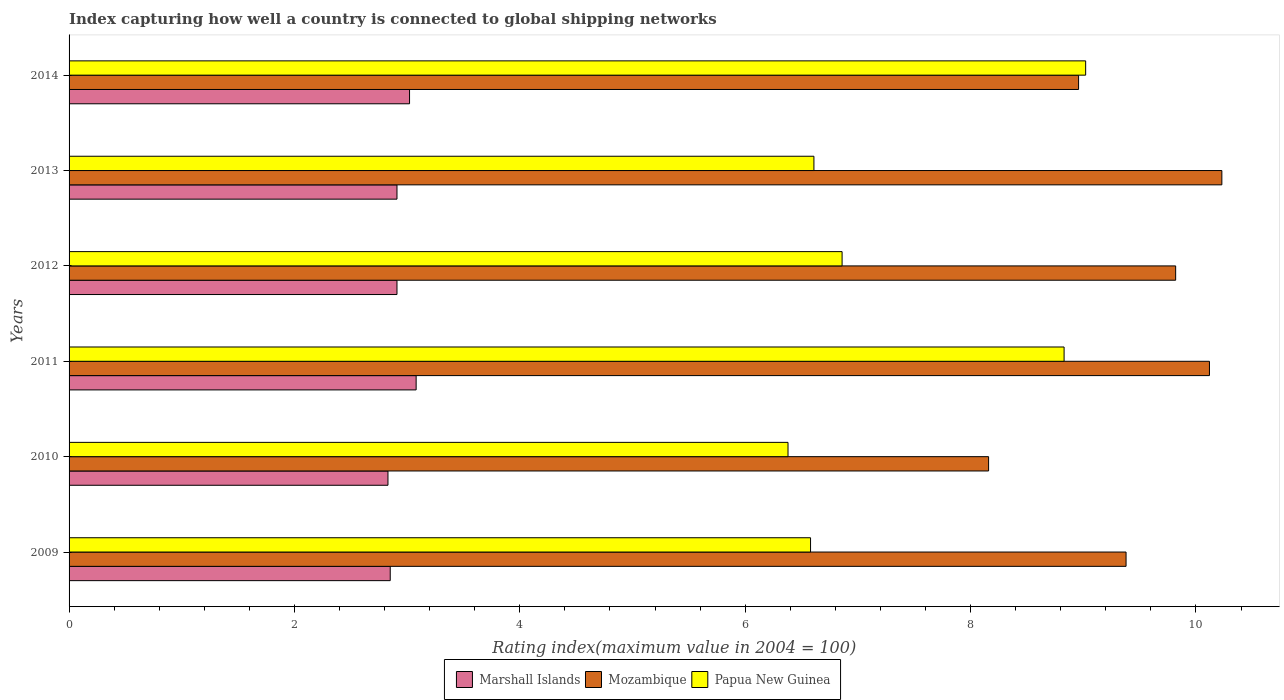How many groups of bars are there?
Offer a very short reply. 6. Are the number of bars on each tick of the Y-axis equal?
Offer a very short reply. Yes. How many bars are there on the 2nd tick from the top?
Provide a short and direct response. 3. How many bars are there on the 4th tick from the bottom?
Your answer should be very brief. 3. What is the rating index in Marshall Islands in 2010?
Provide a short and direct response. 2.83. Across all years, what is the maximum rating index in Mozambique?
Your answer should be compact. 10.23. Across all years, what is the minimum rating index in Papua New Guinea?
Provide a succinct answer. 6.38. In which year was the rating index in Mozambique minimum?
Give a very brief answer. 2010. What is the total rating index in Marshall Islands in the graph?
Your response must be concise. 17.6. What is the difference between the rating index in Papua New Guinea in 2010 and that in 2013?
Your answer should be compact. -0.23. What is the difference between the rating index in Marshall Islands in 2009 and the rating index in Papua New Guinea in 2012?
Make the answer very short. -4.01. What is the average rating index in Papua New Guinea per year?
Give a very brief answer. 7.38. In the year 2010, what is the difference between the rating index in Papua New Guinea and rating index in Mozambique?
Provide a succinct answer. -1.78. In how many years, is the rating index in Marshall Islands greater than 8.8 ?
Your answer should be very brief. 0. What is the ratio of the rating index in Marshall Islands in 2011 to that in 2012?
Your answer should be compact. 1.06. Is the difference between the rating index in Papua New Guinea in 2011 and 2014 greater than the difference between the rating index in Mozambique in 2011 and 2014?
Keep it short and to the point. No. What is the difference between the highest and the second highest rating index in Marshall Islands?
Give a very brief answer. 0.06. What is the difference between the highest and the lowest rating index in Marshall Islands?
Provide a short and direct response. 0.25. In how many years, is the rating index in Mozambique greater than the average rating index in Mozambique taken over all years?
Offer a terse response. 3. What does the 2nd bar from the top in 2011 represents?
Give a very brief answer. Mozambique. What does the 2nd bar from the bottom in 2013 represents?
Provide a short and direct response. Mozambique. Is it the case that in every year, the sum of the rating index in Marshall Islands and rating index in Mozambique is greater than the rating index in Papua New Guinea?
Give a very brief answer. Yes. How many bars are there?
Give a very brief answer. 18. Are all the bars in the graph horizontal?
Offer a very short reply. Yes. Does the graph contain grids?
Keep it short and to the point. No. Where does the legend appear in the graph?
Offer a very short reply. Bottom center. What is the title of the graph?
Make the answer very short. Index capturing how well a country is connected to global shipping networks. What is the label or title of the X-axis?
Your answer should be compact. Rating index(maximum value in 2004 = 100). What is the Rating index(maximum value in 2004 = 100) in Marshall Islands in 2009?
Make the answer very short. 2.85. What is the Rating index(maximum value in 2004 = 100) in Mozambique in 2009?
Ensure brevity in your answer.  9.38. What is the Rating index(maximum value in 2004 = 100) in Papua New Guinea in 2009?
Ensure brevity in your answer.  6.58. What is the Rating index(maximum value in 2004 = 100) of Marshall Islands in 2010?
Offer a very short reply. 2.83. What is the Rating index(maximum value in 2004 = 100) of Mozambique in 2010?
Provide a succinct answer. 8.16. What is the Rating index(maximum value in 2004 = 100) in Papua New Guinea in 2010?
Your response must be concise. 6.38. What is the Rating index(maximum value in 2004 = 100) in Marshall Islands in 2011?
Your response must be concise. 3.08. What is the Rating index(maximum value in 2004 = 100) in Mozambique in 2011?
Offer a terse response. 10.12. What is the Rating index(maximum value in 2004 = 100) of Papua New Guinea in 2011?
Offer a terse response. 8.83. What is the Rating index(maximum value in 2004 = 100) in Marshall Islands in 2012?
Give a very brief answer. 2.91. What is the Rating index(maximum value in 2004 = 100) in Mozambique in 2012?
Provide a succinct answer. 9.82. What is the Rating index(maximum value in 2004 = 100) in Papua New Guinea in 2012?
Your response must be concise. 6.86. What is the Rating index(maximum value in 2004 = 100) of Marshall Islands in 2013?
Ensure brevity in your answer.  2.91. What is the Rating index(maximum value in 2004 = 100) in Mozambique in 2013?
Provide a succinct answer. 10.23. What is the Rating index(maximum value in 2004 = 100) in Papua New Guinea in 2013?
Provide a succinct answer. 6.61. What is the Rating index(maximum value in 2004 = 100) in Marshall Islands in 2014?
Offer a very short reply. 3.02. What is the Rating index(maximum value in 2004 = 100) of Mozambique in 2014?
Your response must be concise. 8.96. What is the Rating index(maximum value in 2004 = 100) in Papua New Guinea in 2014?
Your response must be concise. 9.02. Across all years, what is the maximum Rating index(maximum value in 2004 = 100) in Marshall Islands?
Give a very brief answer. 3.08. Across all years, what is the maximum Rating index(maximum value in 2004 = 100) of Mozambique?
Give a very brief answer. 10.23. Across all years, what is the maximum Rating index(maximum value in 2004 = 100) in Papua New Guinea?
Give a very brief answer. 9.02. Across all years, what is the minimum Rating index(maximum value in 2004 = 100) of Marshall Islands?
Your answer should be compact. 2.83. Across all years, what is the minimum Rating index(maximum value in 2004 = 100) of Mozambique?
Provide a succinct answer. 8.16. Across all years, what is the minimum Rating index(maximum value in 2004 = 100) of Papua New Guinea?
Ensure brevity in your answer.  6.38. What is the total Rating index(maximum value in 2004 = 100) of Marshall Islands in the graph?
Offer a terse response. 17.6. What is the total Rating index(maximum value in 2004 = 100) in Mozambique in the graph?
Provide a short and direct response. 56.67. What is the total Rating index(maximum value in 2004 = 100) in Papua New Guinea in the graph?
Offer a terse response. 44.28. What is the difference between the Rating index(maximum value in 2004 = 100) in Mozambique in 2009 and that in 2010?
Provide a succinct answer. 1.22. What is the difference between the Rating index(maximum value in 2004 = 100) of Marshall Islands in 2009 and that in 2011?
Your answer should be very brief. -0.23. What is the difference between the Rating index(maximum value in 2004 = 100) in Mozambique in 2009 and that in 2011?
Your answer should be very brief. -0.74. What is the difference between the Rating index(maximum value in 2004 = 100) in Papua New Guinea in 2009 and that in 2011?
Your response must be concise. -2.25. What is the difference between the Rating index(maximum value in 2004 = 100) in Marshall Islands in 2009 and that in 2012?
Provide a succinct answer. -0.06. What is the difference between the Rating index(maximum value in 2004 = 100) in Mozambique in 2009 and that in 2012?
Keep it short and to the point. -0.44. What is the difference between the Rating index(maximum value in 2004 = 100) of Papua New Guinea in 2009 and that in 2012?
Provide a short and direct response. -0.28. What is the difference between the Rating index(maximum value in 2004 = 100) of Marshall Islands in 2009 and that in 2013?
Your answer should be very brief. -0.06. What is the difference between the Rating index(maximum value in 2004 = 100) of Mozambique in 2009 and that in 2013?
Your answer should be compact. -0.85. What is the difference between the Rating index(maximum value in 2004 = 100) in Papua New Guinea in 2009 and that in 2013?
Provide a short and direct response. -0.03. What is the difference between the Rating index(maximum value in 2004 = 100) of Marshall Islands in 2009 and that in 2014?
Your answer should be very brief. -0.17. What is the difference between the Rating index(maximum value in 2004 = 100) of Mozambique in 2009 and that in 2014?
Offer a terse response. 0.42. What is the difference between the Rating index(maximum value in 2004 = 100) of Papua New Guinea in 2009 and that in 2014?
Give a very brief answer. -2.44. What is the difference between the Rating index(maximum value in 2004 = 100) in Mozambique in 2010 and that in 2011?
Your response must be concise. -1.96. What is the difference between the Rating index(maximum value in 2004 = 100) in Papua New Guinea in 2010 and that in 2011?
Keep it short and to the point. -2.45. What is the difference between the Rating index(maximum value in 2004 = 100) in Marshall Islands in 2010 and that in 2012?
Provide a succinct answer. -0.08. What is the difference between the Rating index(maximum value in 2004 = 100) of Mozambique in 2010 and that in 2012?
Make the answer very short. -1.66. What is the difference between the Rating index(maximum value in 2004 = 100) of Papua New Guinea in 2010 and that in 2012?
Your answer should be very brief. -0.48. What is the difference between the Rating index(maximum value in 2004 = 100) in Marshall Islands in 2010 and that in 2013?
Your response must be concise. -0.08. What is the difference between the Rating index(maximum value in 2004 = 100) of Mozambique in 2010 and that in 2013?
Keep it short and to the point. -2.07. What is the difference between the Rating index(maximum value in 2004 = 100) in Papua New Guinea in 2010 and that in 2013?
Your answer should be very brief. -0.23. What is the difference between the Rating index(maximum value in 2004 = 100) of Marshall Islands in 2010 and that in 2014?
Offer a terse response. -0.19. What is the difference between the Rating index(maximum value in 2004 = 100) in Mozambique in 2010 and that in 2014?
Your response must be concise. -0.8. What is the difference between the Rating index(maximum value in 2004 = 100) of Papua New Guinea in 2010 and that in 2014?
Your response must be concise. -2.64. What is the difference between the Rating index(maximum value in 2004 = 100) of Marshall Islands in 2011 and that in 2012?
Ensure brevity in your answer.  0.17. What is the difference between the Rating index(maximum value in 2004 = 100) in Papua New Guinea in 2011 and that in 2012?
Keep it short and to the point. 1.97. What is the difference between the Rating index(maximum value in 2004 = 100) of Marshall Islands in 2011 and that in 2013?
Make the answer very short. 0.17. What is the difference between the Rating index(maximum value in 2004 = 100) of Mozambique in 2011 and that in 2013?
Provide a short and direct response. -0.11. What is the difference between the Rating index(maximum value in 2004 = 100) of Papua New Guinea in 2011 and that in 2013?
Provide a short and direct response. 2.22. What is the difference between the Rating index(maximum value in 2004 = 100) of Marshall Islands in 2011 and that in 2014?
Give a very brief answer. 0.06. What is the difference between the Rating index(maximum value in 2004 = 100) of Mozambique in 2011 and that in 2014?
Your answer should be compact. 1.16. What is the difference between the Rating index(maximum value in 2004 = 100) of Papua New Guinea in 2011 and that in 2014?
Offer a terse response. -0.19. What is the difference between the Rating index(maximum value in 2004 = 100) in Mozambique in 2012 and that in 2013?
Your response must be concise. -0.41. What is the difference between the Rating index(maximum value in 2004 = 100) in Papua New Guinea in 2012 and that in 2013?
Ensure brevity in your answer.  0.25. What is the difference between the Rating index(maximum value in 2004 = 100) of Marshall Islands in 2012 and that in 2014?
Keep it short and to the point. -0.11. What is the difference between the Rating index(maximum value in 2004 = 100) of Mozambique in 2012 and that in 2014?
Your answer should be very brief. 0.86. What is the difference between the Rating index(maximum value in 2004 = 100) of Papua New Guinea in 2012 and that in 2014?
Provide a short and direct response. -2.16. What is the difference between the Rating index(maximum value in 2004 = 100) of Marshall Islands in 2013 and that in 2014?
Give a very brief answer. -0.11. What is the difference between the Rating index(maximum value in 2004 = 100) of Mozambique in 2013 and that in 2014?
Offer a terse response. 1.27. What is the difference between the Rating index(maximum value in 2004 = 100) in Papua New Guinea in 2013 and that in 2014?
Ensure brevity in your answer.  -2.41. What is the difference between the Rating index(maximum value in 2004 = 100) in Marshall Islands in 2009 and the Rating index(maximum value in 2004 = 100) in Mozambique in 2010?
Your answer should be compact. -5.31. What is the difference between the Rating index(maximum value in 2004 = 100) of Marshall Islands in 2009 and the Rating index(maximum value in 2004 = 100) of Papua New Guinea in 2010?
Keep it short and to the point. -3.53. What is the difference between the Rating index(maximum value in 2004 = 100) of Mozambique in 2009 and the Rating index(maximum value in 2004 = 100) of Papua New Guinea in 2010?
Offer a terse response. 3. What is the difference between the Rating index(maximum value in 2004 = 100) in Marshall Islands in 2009 and the Rating index(maximum value in 2004 = 100) in Mozambique in 2011?
Provide a succinct answer. -7.27. What is the difference between the Rating index(maximum value in 2004 = 100) of Marshall Islands in 2009 and the Rating index(maximum value in 2004 = 100) of Papua New Guinea in 2011?
Offer a terse response. -5.98. What is the difference between the Rating index(maximum value in 2004 = 100) in Mozambique in 2009 and the Rating index(maximum value in 2004 = 100) in Papua New Guinea in 2011?
Give a very brief answer. 0.55. What is the difference between the Rating index(maximum value in 2004 = 100) of Marshall Islands in 2009 and the Rating index(maximum value in 2004 = 100) of Mozambique in 2012?
Offer a terse response. -6.97. What is the difference between the Rating index(maximum value in 2004 = 100) of Marshall Islands in 2009 and the Rating index(maximum value in 2004 = 100) of Papua New Guinea in 2012?
Your answer should be compact. -4.01. What is the difference between the Rating index(maximum value in 2004 = 100) in Mozambique in 2009 and the Rating index(maximum value in 2004 = 100) in Papua New Guinea in 2012?
Provide a succinct answer. 2.52. What is the difference between the Rating index(maximum value in 2004 = 100) of Marshall Islands in 2009 and the Rating index(maximum value in 2004 = 100) of Mozambique in 2013?
Give a very brief answer. -7.38. What is the difference between the Rating index(maximum value in 2004 = 100) in Marshall Islands in 2009 and the Rating index(maximum value in 2004 = 100) in Papua New Guinea in 2013?
Make the answer very short. -3.76. What is the difference between the Rating index(maximum value in 2004 = 100) of Mozambique in 2009 and the Rating index(maximum value in 2004 = 100) of Papua New Guinea in 2013?
Keep it short and to the point. 2.77. What is the difference between the Rating index(maximum value in 2004 = 100) in Marshall Islands in 2009 and the Rating index(maximum value in 2004 = 100) in Mozambique in 2014?
Your answer should be very brief. -6.11. What is the difference between the Rating index(maximum value in 2004 = 100) in Marshall Islands in 2009 and the Rating index(maximum value in 2004 = 100) in Papua New Guinea in 2014?
Give a very brief answer. -6.17. What is the difference between the Rating index(maximum value in 2004 = 100) in Mozambique in 2009 and the Rating index(maximum value in 2004 = 100) in Papua New Guinea in 2014?
Keep it short and to the point. 0.36. What is the difference between the Rating index(maximum value in 2004 = 100) of Marshall Islands in 2010 and the Rating index(maximum value in 2004 = 100) of Mozambique in 2011?
Your answer should be compact. -7.29. What is the difference between the Rating index(maximum value in 2004 = 100) in Mozambique in 2010 and the Rating index(maximum value in 2004 = 100) in Papua New Guinea in 2011?
Your answer should be compact. -0.67. What is the difference between the Rating index(maximum value in 2004 = 100) of Marshall Islands in 2010 and the Rating index(maximum value in 2004 = 100) of Mozambique in 2012?
Offer a terse response. -6.99. What is the difference between the Rating index(maximum value in 2004 = 100) of Marshall Islands in 2010 and the Rating index(maximum value in 2004 = 100) of Papua New Guinea in 2012?
Your answer should be very brief. -4.03. What is the difference between the Rating index(maximum value in 2004 = 100) of Marshall Islands in 2010 and the Rating index(maximum value in 2004 = 100) of Mozambique in 2013?
Offer a terse response. -7.4. What is the difference between the Rating index(maximum value in 2004 = 100) of Marshall Islands in 2010 and the Rating index(maximum value in 2004 = 100) of Papua New Guinea in 2013?
Your response must be concise. -3.78. What is the difference between the Rating index(maximum value in 2004 = 100) in Mozambique in 2010 and the Rating index(maximum value in 2004 = 100) in Papua New Guinea in 2013?
Offer a very short reply. 1.55. What is the difference between the Rating index(maximum value in 2004 = 100) in Marshall Islands in 2010 and the Rating index(maximum value in 2004 = 100) in Mozambique in 2014?
Provide a short and direct response. -6.13. What is the difference between the Rating index(maximum value in 2004 = 100) in Marshall Islands in 2010 and the Rating index(maximum value in 2004 = 100) in Papua New Guinea in 2014?
Your answer should be compact. -6.19. What is the difference between the Rating index(maximum value in 2004 = 100) in Mozambique in 2010 and the Rating index(maximum value in 2004 = 100) in Papua New Guinea in 2014?
Provide a short and direct response. -0.86. What is the difference between the Rating index(maximum value in 2004 = 100) of Marshall Islands in 2011 and the Rating index(maximum value in 2004 = 100) of Mozambique in 2012?
Your answer should be compact. -6.74. What is the difference between the Rating index(maximum value in 2004 = 100) of Marshall Islands in 2011 and the Rating index(maximum value in 2004 = 100) of Papua New Guinea in 2012?
Provide a short and direct response. -3.78. What is the difference between the Rating index(maximum value in 2004 = 100) of Mozambique in 2011 and the Rating index(maximum value in 2004 = 100) of Papua New Guinea in 2012?
Offer a terse response. 3.26. What is the difference between the Rating index(maximum value in 2004 = 100) of Marshall Islands in 2011 and the Rating index(maximum value in 2004 = 100) of Mozambique in 2013?
Your answer should be very brief. -7.15. What is the difference between the Rating index(maximum value in 2004 = 100) in Marshall Islands in 2011 and the Rating index(maximum value in 2004 = 100) in Papua New Guinea in 2013?
Your answer should be very brief. -3.53. What is the difference between the Rating index(maximum value in 2004 = 100) in Mozambique in 2011 and the Rating index(maximum value in 2004 = 100) in Papua New Guinea in 2013?
Offer a very short reply. 3.51. What is the difference between the Rating index(maximum value in 2004 = 100) in Marshall Islands in 2011 and the Rating index(maximum value in 2004 = 100) in Mozambique in 2014?
Make the answer very short. -5.88. What is the difference between the Rating index(maximum value in 2004 = 100) of Marshall Islands in 2011 and the Rating index(maximum value in 2004 = 100) of Papua New Guinea in 2014?
Give a very brief answer. -5.94. What is the difference between the Rating index(maximum value in 2004 = 100) in Mozambique in 2011 and the Rating index(maximum value in 2004 = 100) in Papua New Guinea in 2014?
Provide a short and direct response. 1.1. What is the difference between the Rating index(maximum value in 2004 = 100) of Marshall Islands in 2012 and the Rating index(maximum value in 2004 = 100) of Mozambique in 2013?
Offer a very short reply. -7.32. What is the difference between the Rating index(maximum value in 2004 = 100) of Mozambique in 2012 and the Rating index(maximum value in 2004 = 100) of Papua New Guinea in 2013?
Make the answer very short. 3.21. What is the difference between the Rating index(maximum value in 2004 = 100) of Marshall Islands in 2012 and the Rating index(maximum value in 2004 = 100) of Mozambique in 2014?
Offer a terse response. -6.05. What is the difference between the Rating index(maximum value in 2004 = 100) in Marshall Islands in 2012 and the Rating index(maximum value in 2004 = 100) in Papua New Guinea in 2014?
Keep it short and to the point. -6.11. What is the difference between the Rating index(maximum value in 2004 = 100) in Mozambique in 2012 and the Rating index(maximum value in 2004 = 100) in Papua New Guinea in 2014?
Give a very brief answer. 0.8. What is the difference between the Rating index(maximum value in 2004 = 100) of Marshall Islands in 2013 and the Rating index(maximum value in 2004 = 100) of Mozambique in 2014?
Make the answer very short. -6.05. What is the difference between the Rating index(maximum value in 2004 = 100) in Marshall Islands in 2013 and the Rating index(maximum value in 2004 = 100) in Papua New Guinea in 2014?
Keep it short and to the point. -6.11. What is the difference between the Rating index(maximum value in 2004 = 100) of Mozambique in 2013 and the Rating index(maximum value in 2004 = 100) of Papua New Guinea in 2014?
Offer a very short reply. 1.21. What is the average Rating index(maximum value in 2004 = 100) of Marshall Islands per year?
Make the answer very short. 2.93. What is the average Rating index(maximum value in 2004 = 100) in Mozambique per year?
Your answer should be compact. 9.44. What is the average Rating index(maximum value in 2004 = 100) in Papua New Guinea per year?
Ensure brevity in your answer.  7.38. In the year 2009, what is the difference between the Rating index(maximum value in 2004 = 100) in Marshall Islands and Rating index(maximum value in 2004 = 100) in Mozambique?
Offer a terse response. -6.53. In the year 2009, what is the difference between the Rating index(maximum value in 2004 = 100) in Marshall Islands and Rating index(maximum value in 2004 = 100) in Papua New Guinea?
Provide a succinct answer. -3.73. In the year 2010, what is the difference between the Rating index(maximum value in 2004 = 100) in Marshall Islands and Rating index(maximum value in 2004 = 100) in Mozambique?
Ensure brevity in your answer.  -5.33. In the year 2010, what is the difference between the Rating index(maximum value in 2004 = 100) of Marshall Islands and Rating index(maximum value in 2004 = 100) of Papua New Guinea?
Offer a very short reply. -3.55. In the year 2010, what is the difference between the Rating index(maximum value in 2004 = 100) in Mozambique and Rating index(maximum value in 2004 = 100) in Papua New Guinea?
Ensure brevity in your answer.  1.78. In the year 2011, what is the difference between the Rating index(maximum value in 2004 = 100) of Marshall Islands and Rating index(maximum value in 2004 = 100) of Mozambique?
Offer a terse response. -7.04. In the year 2011, what is the difference between the Rating index(maximum value in 2004 = 100) in Marshall Islands and Rating index(maximum value in 2004 = 100) in Papua New Guinea?
Your answer should be compact. -5.75. In the year 2011, what is the difference between the Rating index(maximum value in 2004 = 100) in Mozambique and Rating index(maximum value in 2004 = 100) in Papua New Guinea?
Offer a very short reply. 1.29. In the year 2012, what is the difference between the Rating index(maximum value in 2004 = 100) in Marshall Islands and Rating index(maximum value in 2004 = 100) in Mozambique?
Provide a succinct answer. -6.91. In the year 2012, what is the difference between the Rating index(maximum value in 2004 = 100) in Marshall Islands and Rating index(maximum value in 2004 = 100) in Papua New Guinea?
Give a very brief answer. -3.95. In the year 2012, what is the difference between the Rating index(maximum value in 2004 = 100) in Mozambique and Rating index(maximum value in 2004 = 100) in Papua New Guinea?
Your answer should be very brief. 2.96. In the year 2013, what is the difference between the Rating index(maximum value in 2004 = 100) of Marshall Islands and Rating index(maximum value in 2004 = 100) of Mozambique?
Provide a succinct answer. -7.32. In the year 2013, what is the difference between the Rating index(maximum value in 2004 = 100) in Marshall Islands and Rating index(maximum value in 2004 = 100) in Papua New Guinea?
Keep it short and to the point. -3.7. In the year 2013, what is the difference between the Rating index(maximum value in 2004 = 100) of Mozambique and Rating index(maximum value in 2004 = 100) of Papua New Guinea?
Your response must be concise. 3.62. In the year 2014, what is the difference between the Rating index(maximum value in 2004 = 100) in Marshall Islands and Rating index(maximum value in 2004 = 100) in Mozambique?
Your response must be concise. -5.94. In the year 2014, what is the difference between the Rating index(maximum value in 2004 = 100) in Marshall Islands and Rating index(maximum value in 2004 = 100) in Papua New Guinea?
Offer a very short reply. -6. In the year 2014, what is the difference between the Rating index(maximum value in 2004 = 100) of Mozambique and Rating index(maximum value in 2004 = 100) of Papua New Guinea?
Make the answer very short. -0.06. What is the ratio of the Rating index(maximum value in 2004 = 100) of Marshall Islands in 2009 to that in 2010?
Provide a short and direct response. 1.01. What is the ratio of the Rating index(maximum value in 2004 = 100) of Mozambique in 2009 to that in 2010?
Ensure brevity in your answer.  1.15. What is the ratio of the Rating index(maximum value in 2004 = 100) in Papua New Guinea in 2009 to that in 2010?
Your answer should be very brief. 1.03. What is the ratio of the Rating index(maximum value in 2004 = 100) in Marshall Islands in 2009 to that in 2011?
Offer a terse response. 0.93. What is the ratio of the Rating index(maximum value in 2004 = 100) of Mozambique in 2009 to that in 2011?
Keep it short and to the point. 0.93. What is the ratio of the Rating index(maximum value in 2004 = 100) of Papua New Guinea in 2009 to that in 2011?
Provide a short and direct response. 0.75. What is the ratio of the Rating index(maximum value in 2004 = 100) in Marshall Islands in 2009 to that in 2012?
Offer a terse response. 0.98. What is the ratio of the Rating index(maximum value in 2004 = 100) in Mozambique in 2009 to that in 2012?
Provide a short and direct response. 0.96. What is the ratio of the Rating index(maximum value in 2004 = 100) in Papua New Guinea in 2009 to that in 2012?
Make the answer very short. 0.96. What is the ratio of the Rating index(maximum value in 2004 = 100) of Marshall Islands in 2009 to that in 2013?
Your answer should be compact. 0.98. What is the ratio of the Rating index(maximum value in 2004 = 100) of Mozambique in 2009 to that in 2013?
Provide a short and direct response. 0.92. What is the ratio of the Rating index(maximum value in 2004 = 100) of Marshall Islands in 2009 to that in 2014?
Give a very brief answer. 0.94. What is the ratio of the Rating index(maximum value in 2004 = 100) in Mozambique in 2009 to that in 2014?
Provide a short and direct response. 1.05. What is the ratio of the Rating index(maximum value in 2004 = 100) in Papua New Guinea in 2009 to that in 2014?
Give a very brief answer. 0.73. What is the ratio of the Rating index(maximum value in 2004 = 100) of Marshall Islands in 2010 to that in 2011?
Provide a short and direct response. 0.92. What is the ratio of the Rating index(maximum value in 2004 = 100) in Mozambique in 2010 to that in 2011?
Give a very brief answer. 0.81. What is the ratio of the Rating index(maximum value in 2004 = 100) in Papua New Guinea in 2010 to that in 2011?
Ensure brevity in your answer.  0.72. What is the ratio of the Rating index(maximum value in 2004 = 100) in Marshall Islands in 2010 to that in 2012?
Ensure brevity in your answer.  0.97. What is the ratio of the Rating index(maximum value in 2004 = 100) of Mozambique in 2010 to that in 2012?
Provide a succinct answer. 0.83. What is the ratio of the Rating index(maximum value in 2004 = 100) of Papua New Guinea in 2010 to that in 2012?
Provide a short and direct response. 0.93. What is the ratio of the Rating index(maximum value in 2004 = 100) in Marshall Islands in 2010 to that in 2013?
Keep it short and to the point. 0.97. What is the ratio of the Rating index(maximum value in 2004 = 100) in Mozambique in 2010 to that in 2013?
Provide a succinct answer. 0.8. What is the ratio of the Rating index(maximum value in 2004 = 100) of Papua New Guinea in 2010 to that in 2013?
Give a very brief answer. 0.97. What is the ratio of the Rating index(maximum value in 2004 = 100) in Marshall Islands in 2010 to that in 2014?
Your response must be concise. 0.94. What is the ratio of the Rating index(maximum value in 2004 = 100) in Mozambique in 2010 to that in 2014?
Provide a succinct answer. 0.91. What is the ratio of the Rating index(maximum value in 2004 = 100) in Papua New Guinea in 2010 to that in 2014?
Your answer should be very brief. 0.71. What is the ratio of the Rating index(maximum value in 2004 = 100) in Marshall Islands in 2011 to that in 2012?
Provide a succinct answer. 1.06. What is the ratio of the Rating index(maximum value in 2004 = 100) of Mozambique in 2011 to that in 2012?
Your answer should be compact. 1.03. What is the ratio of the Rating index(maximum value in 2004 = 100) of Papua New Guinea in 2011 to that in 2012?
Provide a succinct answer. 1.29. What is the ratio of the Rating index(maximum value in 2004 = 100) in Marshall Islands in 2011 to that in 2013?
Provide a succinct answer. 1.06. What is the ratio of the Rating index(maximum value in 2004 = 100) in Papua New Guinea in 2011 to that in 2013?
Your response must be concise. 1.34. What is the ratio of the Rating index(maximum value in 2004 = 100) of Marshall Islands in 2011 to that in 2014?
Provide a succinct answer. 1.02. What is the ratio of the Rating index(maximum value in 2004 = 100) of Mozambique in 2011 to that in 2014?
Offer a terse response. 1.13. What is the ratio of the Rating index(maximum value in 2004 = 100) in Papua New Guinea in 2011 to that in 2014?
Your response must be concise. 0.98. What is the ratio of the Rating index(maximum value in 2004 = 100) of Marshall Islands in 2012 to that in 2013?
Give a very brief answer. 1. What is the ratio of the Rating index(maximum value in 2004 = 100) of Mozambique in 2012 to that in 2013?
Your answer should be very brief. 0.96. What is the ratio of the Rating index(maximum value in 2004 = 100) in Papua New Guinea in 2012 to that in 2013?
Your answer should be very brief. 1.04. What is the ratio of the Rating index(maximum value in 2004 = 100) in Marshall Islands in 2012 to that in 2014?
Provide a succinct answer. 0.96. What is the ratio of the Rating index(maximum value in 2004 = 100) of Mozambique in 2012 to that in 2014?
Your answer should be very brief. 1.1. What is the ratio of the Rating index(maximum value in 2004 = 100) in Papua New Guinea in 2012 to that in 2014?
Your answer should be compact. 0.76. What is the ratio of the Rating index(maximum value in 2004 = 100) in Marshall Islands in 2013 to that in 2014?
Your answer should be very brief. 0.96. What is the ratio of the Rating index(maximum value in 2004 = 100) in Mozambique in 2013 to that in 2014?
Provide a succinct answer. 1.14. What is the ratio of the Rating index(maximum value in 2004 = 100) in Papua New Guinea in 2013 to that in 2014?
Provide a succinct answer. 0.73. What is the difference between the highest and the second highest Rating index(maximum value in 2004 = 100) of Marshall Islands?
Your response must be concise. 0.06. What is the difference between the highest and the second highest Rating index(maximum value in 2004 = 100) of Mozambique?
Provide a short and direct response. 0.11. What is the difference between the highest and the second highest Rating index(maximum value in 2004 = 100) of Papua New Guinea?
Offer a terse response. 0.19. What is the difference between the highest and the lowest Rating index(maximum value in 2004 = 100) in Mozambique?
Offer a very short reply. 2.07. What is the difference between the highest and the lowest Rating index(maximum value in 2004 = 100) in Papua New Guinea?
Ensure brevity in your answer.  2.64. 